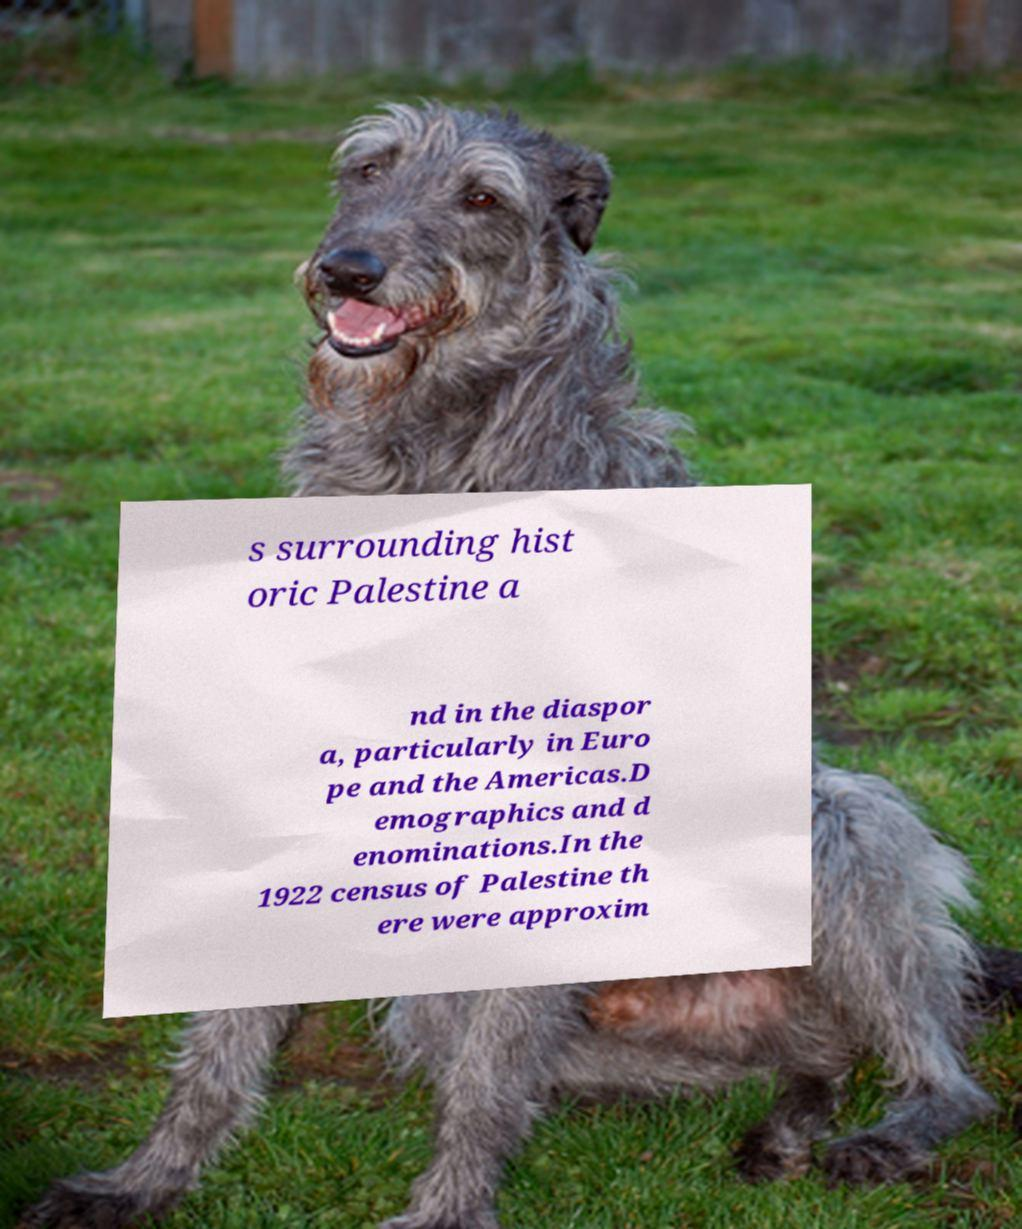I need the written content from this picture converted into text. Can you do that? s surrounding hist oric Palestine a nd in the diaspor a, particularly in Euro pe and the Americas.D emographics and d enominations.In the 1922 census of Palestine th ere were approxim 